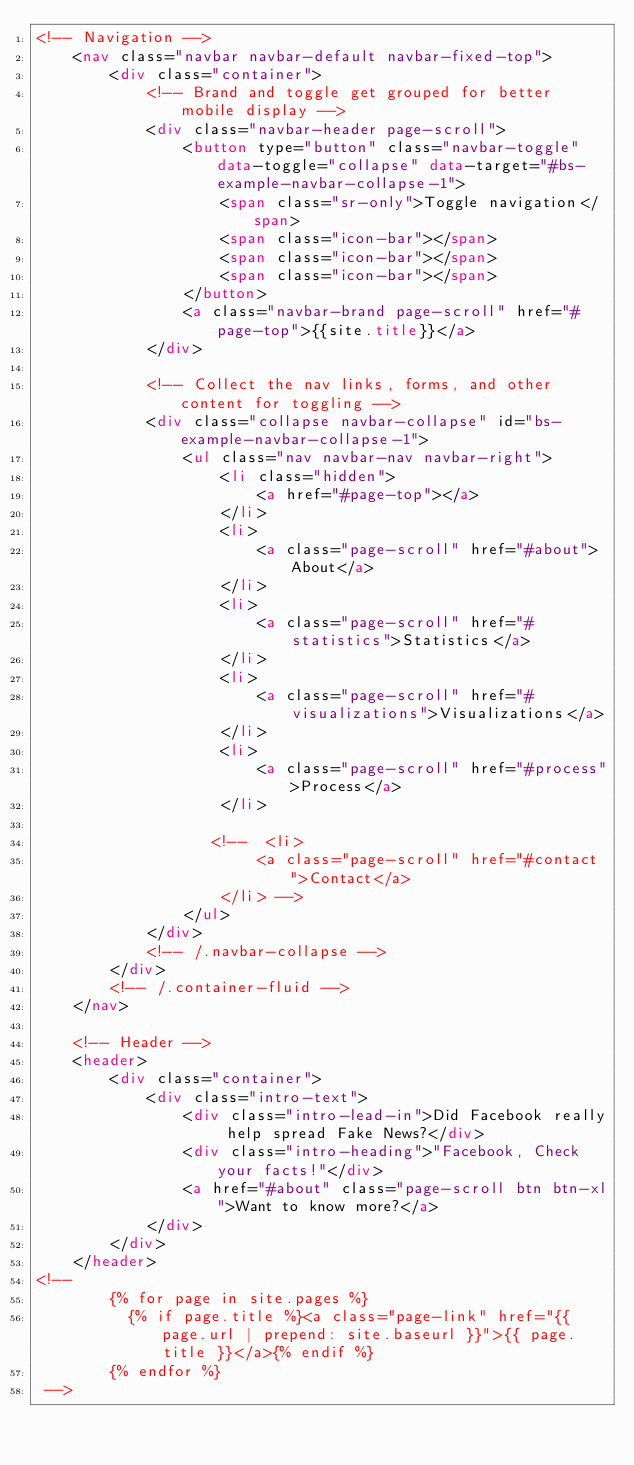Convert code to text. <code><loc_0><loc_0><loc_500><loc_500><_HTML_><!-- Navigation -->
    <nav class="navbar navbar-default navbar-fixed-top">
        <div class="container">
            <!-- Brand and toggle get grouped for better mobile display -->
            <div class="navbar-header page-scroll">
                <button type="button" class="navbar-toggle" data-toggle="collapse" data-target="#bs-example-navbar-collapse-1">
                    <span class="sr-only">Toggle navigation</span>
                    <span class="icon-bar"></span>
                    <span class="icon-bar"></span>
                    <span class="icon-bar"></span>
                </button>
                <a class="navbar-brand page-scroll" href="#page-top">{{site.title}}</a>
            </div>

            <!-- Collect the nav links, forms, and other content for toggling -->
            <div class="collapse navbar-collapse" id="bs-example-navbar-collapse-1">
                <ul class="nav navbar-nav navbar-right">
                    <li class="hidden">
                        <a href="#page-top"></a>
                    </li>
                    <li>
                        <a class="page-scroll" href="#about">About</a>
                    </li>
                    <li>
                        <a class="page-scroll" href="#statistics">Statistics</a>
                    </li>
                    <li>
                        <a class="page-scroll" href="#visualizations">Visualizations</a>
                    </li>
                    <li>
                        <a class="page-scroll" href="#process">Process</a>
                    </li>
                    
                   <!--  <li>
                        <a class="page-scroll" href="#contact">Contact</a>
                    </li> -->
                </ul>
            </div>
            <!-- /.navbar-collapse -->
        </div>
        <!-- /.container-fluid -->
    </nav>

    <!-- Header -->
    <header>
        <div class="container">
            <div class="intro-text">
                <div class="intro-lead-in">Did Facebook really help spread Fake News?</div>
                <div class="intro-heading">"Facebook, Check your facts!"</div>
                <a href="#about" class="page-scroll btn btn-xl">Want to know more?</a>
            </div>
        </div>
    </header>
<!--
        {% for page in site.pages %}
          {% if page.title %}<a class="page-link" href="{{ page.url | prepend: site.baseurl }}">{{ page.title }}</a>{% endif %}
        {% endfor %}
 -->

</code> 